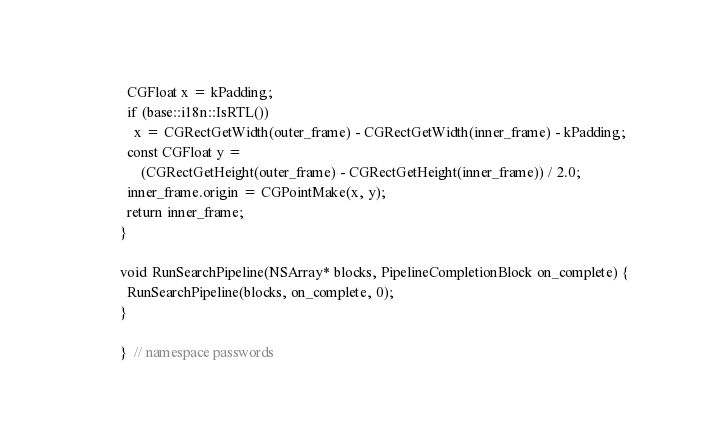Convert code to text. <code><loc_0><loc_0><loc_500><loc_500><_ObjectiveC_>  CGFloat x = kPadding;
  if (base::i18n::IsRTL())
    x = CGRectGetWidth(outer_frame) - CGRectGetWidth(inner_frame) - kPadding;
  const CGFloat y =
      (CGRectGetHeight(outer_frame) - CGRectGetHeight(inner_frame)) / 2.0;
  inner_frame.origin = CGPointMake(x, y);
  return inner_frame;
}

void RunSearchPipeline(NSArray* blocks, PipelineCompletionBlock on_complete) {
  RunSearchPipeline(blocks, on_complete, 0);
}

}  // namespace passwords
</code> 